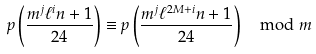<formula> <loc_0><loc_0><loc_500><loc_500>p \left ( \frac { m ^ { j } \ell ^ { i } n + 1 } { 2 4 } \right ) \equiv p \left ( \frac { m ^ { j } \ell ^ { 2 M + i } n + 1 } { 2 4 } \right ) \mod m</formula> 